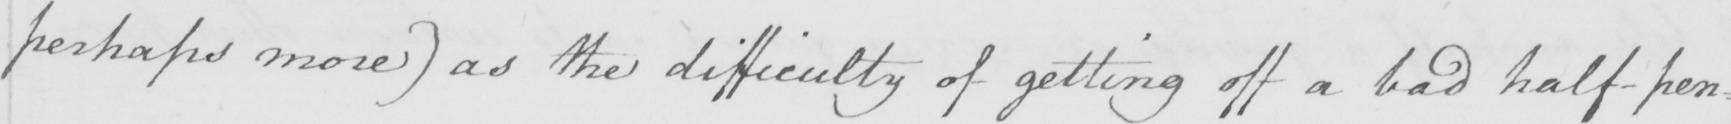Please provide the text content of this handwritten line. perhaps more )  as the difficulty of getting off a bad half-pen= 